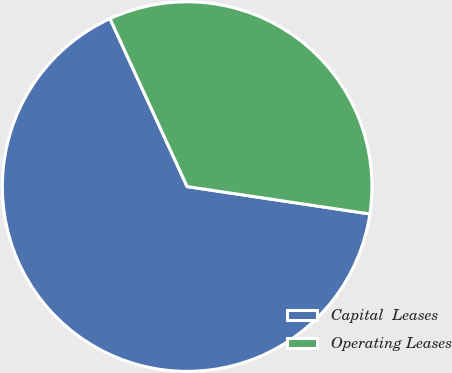Convert chart. <chart><loc_0><loc_0><loc_500><loc_500><pie_chart><fcel>Capital  Leases<fcel>Operating Leases<nl><fcel>65.78%<fcel>34.22%<nl></chart> 